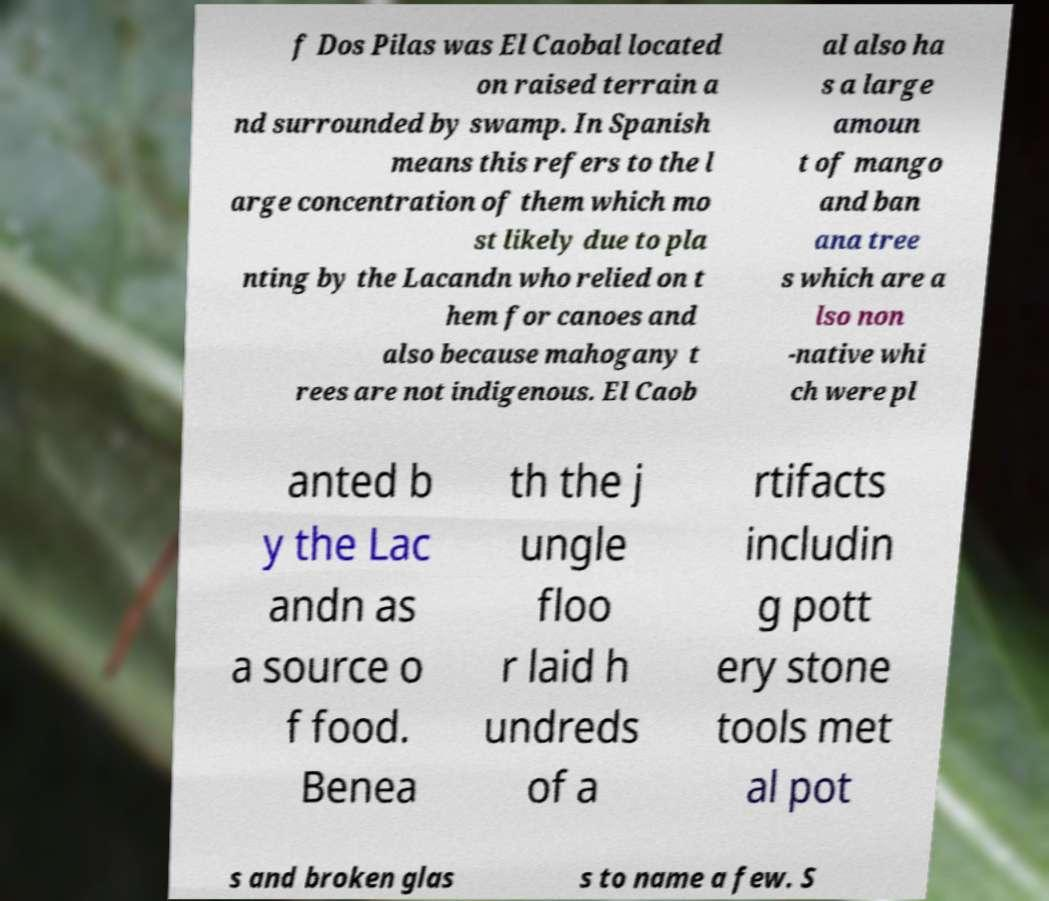Could you extract and type out the text from this image? f Dos Pilas was El Caobal located on raised terrain a nd surrounded by swamp. In Spanish means this refers to the l arge concentration of them which mo st likely due to pla nting by the Lacandn who relied on t hem for canoes and also because mahogany t rees are not indigenous. El Caob al also ha s a large amoun t of mango and ban ana tree s which are a lso non -native whi ch were pl anted b y the Lac andn as a source o f food. Benea th the j ungle floo r laid h undreds of a rtifacts includin g pott ery stone tools met al pot s and broken glas s to name a few. S 